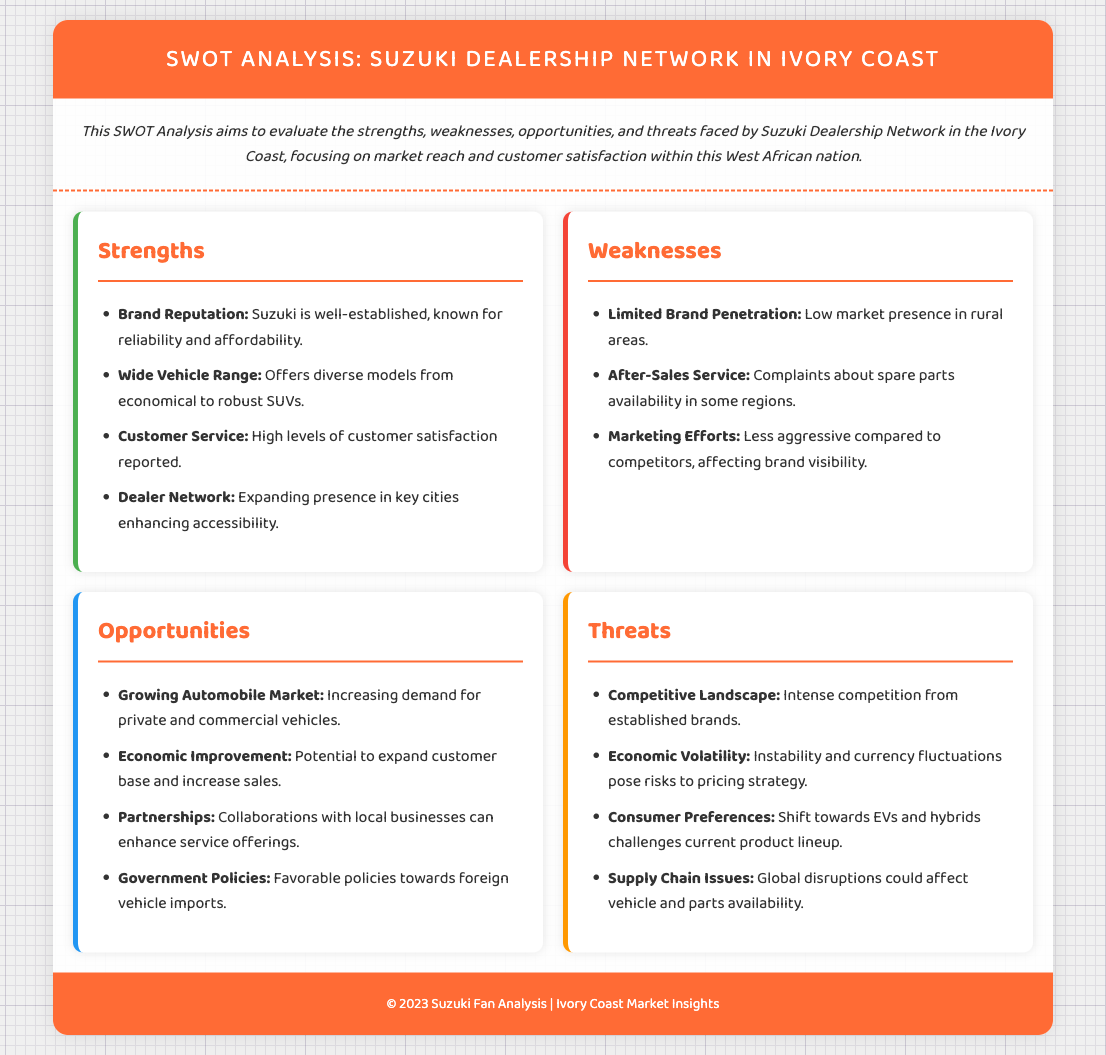What is one strength of the Suzuki dealership network? The document lists advantages such as "Brand Reputation" and "Wide Vehicle Range" under strengths.
Answer: Brand Reputation What is a weakness related to after-sales service? The document specifically mentions issues related to spare parts availability as a weakness.
Answer: Spare parts availability What opportunity exists due to government actions? The document notes "Favorable policies towards foreign vehicle imports" as an opportunity.
Answer: Favorable policies What threat relates to changing consumer preferences? The document states that "Shift towards EVs and hybrids challenges current product lineup" which highlights the challenge posed by new vehicle types.
Answer: Shift towards EVs and hybrids How many strengths are listed in the document? By counting the corresponding entries in the strengths section, there are four strengths mentioned.
Answer: Four What is the color used for the weaknesses section in the document? The design of the document indicates that sections have specific border colors, with weaknesses marked in red.
Answer: Red What aspect of the market is expected to grow? The document specifically points out the "Growing Automobile Market" as an area of opportunity.
Answer: Growing Automobile Market What is one reported customer satisfaction aspect? The document indicates that "High levels of customer satisfaction reported" in the strengths section.
Answer: High levels of customer satisfaction 